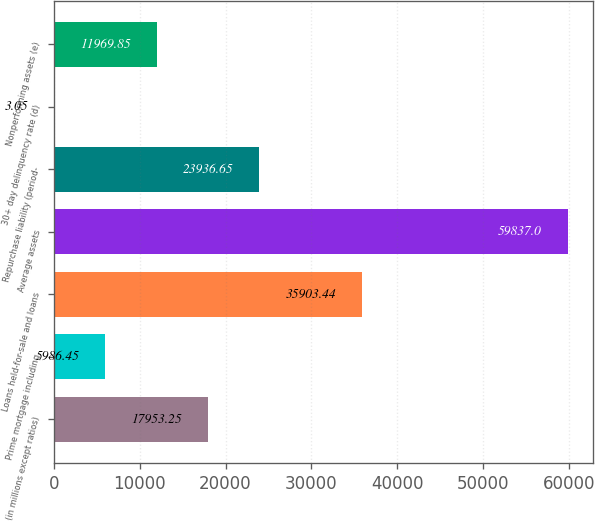Convert chart. <chart><loc_0><loc_0><loc_500><loc_500><bar_chart><fcel>(in millions except ratios)<fcel>Prime mortgage including<fcel>Loans held-for-sale and loans<fcel>Average assets<fcel>Repurchase liability (period-<fcel>30+ day delinquency rate (d)<fcel>Nonperforming assets (e)<nl><fcel>17953.2<fcel>5986.45<fcel>35903.4<fcel>59837<fcel>23936.7<fcel>3.05<fcel>11969.9<nl></chart> 